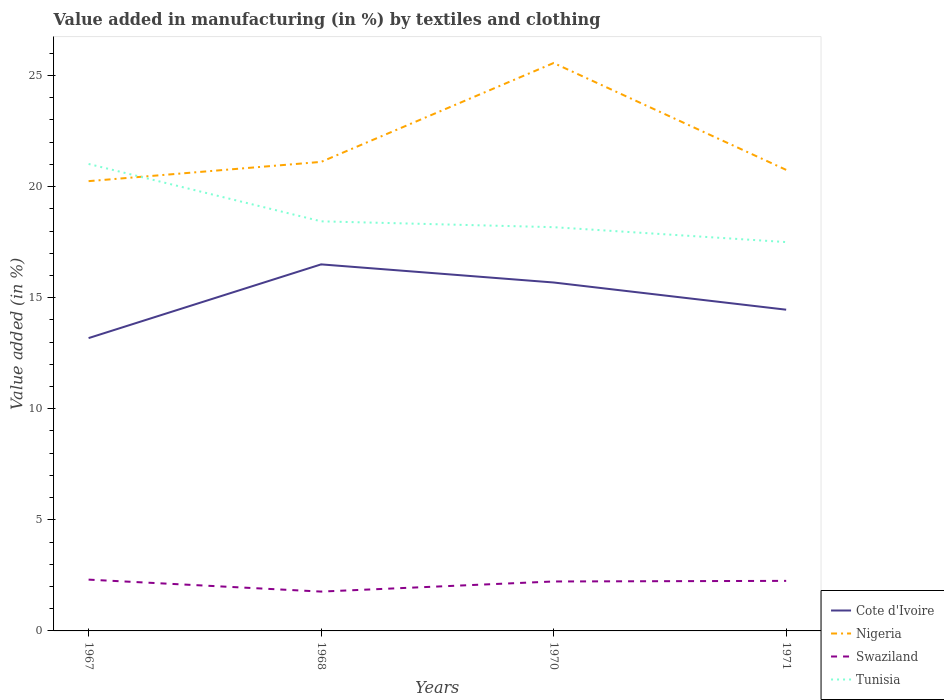Does the line corresponding to Cote d'Ivoire intersect with the line corresponding to Nigeria?
Offer a terse response. No. Is the number of lines equal to the number of legend labels?
Provide a succinct answer. Yes. Across all years, what is the maximum percentage of value added in manufacturing by textiles and clothing in Tunisia?
Your answer should be compact. 17.5. In which year was the percentage of value added in manufacturing by textiles and clothing in Swaziland maximum?
Provide a short and direct response. 1968. What is the total percentage of value added in manufacturing by textiles and clothing in Cote d'Ivoire in the graph?
Provide a short and direct response. 0.82. What is the difference between the highest and the second highest percentage of value added in manufacturing by textiles and clothing in Nigeria?
Your response must be concise. 5.32. How many lines are there?
Give a very brief answer. 4. Does the graph contain grids?
Give a very brief answer. No. How many legend labels are there?
Make the answer very short. 4. How are the legend labels stacked?
Your response must be concise. Vertical. What is the title of the graph?
Provide a succinct answer. Value added in manufacturing (in %) by textiles and clothing. What is the label or title of the Y-axis?
Offer a terse response. Value added (in %). What is the Value added (in %) in Cote d'Ivoire in 1967?
Make the answer very short. 13.18. What is the Value added (in %) in Nigeria in 1967?
Provide a short and direct response. 20.25. What is the Value added (in %) in Swaziland in 1967?
Keep it short and to the point. 2.31. What is the Value added (in %) of Tunisia in 1967?
Offer a terse response. 21.02. What is the Value added (in %) in Cote d'Ivoire in 1968?
Offer a very short reply. 16.5. What is the Value added (in %) of Nigeria in 1968?
Ensure brevity in your answer.  21.11. What is the Value added (in %) in Swaziland in 1968?
Your response must be concise. 1.77. What is the Value added (in %) of Tunisia in 1968?
Your answer should be very brief. 18.44. What is the Value added (in %) of Cote d'Ivoire in 1970?
Give a very brief answer. 15.68. What is the Value added (in %) of Nigeria in 1970?
Ensure brevity in your answer.  25.57. What is the Value added (in %) of Swaziland in 1970?
Provide a short and direct response. 2.23. What is the Value added (in %) in Tunisia in 1970?
Offer a terse response. 18.18. What is the Value added (in %) in Cote d'Ivoire in 1971?
Your answer should be very brief. 14.46. What is the Value added (in %) in Nigeria in 1971?
Offer a very short reply. 20.75. What is the Value added (in %) of Swaziland in 1971?
Your answer should be very brief. 2.25. What is the Value added (in %) of Tunisia in 1971?
Give a very brief answer. 17.5. Across all years, what is the maximum Value added (in %) in Cote d'Ivoire?
Offer a very short reply. 16.5. Across all years, what is the maximum Value added (in %) of Nigeria?
Your response must be concise. 25.57. Across all years, what is the maximum Value added (in %) of Swaziland?
Give a very brief answer. 2.31. Across all years, what is the maximum Value added (in %) of Tunisia?
Give a very brief answer. 21.02. Across all years, what is the minimum Value added (in %) in Cote d'Ivoire?
Your response must be concise. 13.18. Across all years, what is the minimum Value added (in %) of Nigeria?
Offer a very short reply. 20.25. Across all years, what is the minimum Value added (in %) in Swaziland?
Give a very brief answer. 1.77. Across all years, what is the minimum Value added (in %) in Tunisia?
Provide a short and direct response. 17.5. What is the total Value added (in %) of Cote d'Ivoire in the graph?
Ensure brevity in your answer.  59.83. What is the total Value added (in %) in Nigeria in the graph?
Make the answer very short. 87.68. What is the total Value added (in %) in Swaziland in the graph?
Your answer should be very brief. 8.56. What is the total Value added (in %) in Tunisia in the graph?
Keep it short and to the point. 75.14. What is the difference between the Value added (in %) in Cote d'Ivoire in 1967 and that in 1968?
Your response must be concise. -3.32. What is the difference between the Value added (in %) in Nigeria in 1967 and that in 1968?
Give a very brief answer. -0.87. What is the difference between the Value added (in %) in Swaziland in 1967 and that in 1968?
Your response must be concise. 0.54. What is the difference between the Value added (in %) of Tunisia in 1967 and that in 1968?
Your response must be concise. 2.58. What is the difference between the Value added (in %) in Cote d'Ivoire in 1967 and that in 1970?
Provide a succinct answer. -2.5. What is the difference between the Value added (in %) of Nigeria in 1967 and that in 1970?
Keep it short and to the point. -5.32. What is the difference between the Value added (in %) of Swaziland in 1967 and that in 1970?
Your response must be concise. 0.08. What is the difference between the Value added (in %) in Tunisia in 1967 and that in 1970?
Ensure brevity in your answer.  2.85. What is the difference between the Value added (in %) of Cote d'Ivoire in 1967 and that in 1971?
Provide a succinct answer. -1.28. What is the difference between the Value added (in %) of Nigeria in 1967 and that in 1971?
Ensure brevity in your answer.  -0.51. What is the difference between the Value added (in %) in Swaziland in 1967 and that in 1971?
Keep it short and to the point. 0.06. What is the difference between the Value added (in %) in Tunisia in 1967 and that in 1971?
Your response must be concise. 3.52. What is the difference between the Value added (in %) of Cote d'Ivoire in 1968 and that in 1970?
Your answer should be compact. 0.82. What is the difference between the Value added (in %) in Nigeria in 1968 and that in 1970?
Your answer should be compact. -4.45. What is the difference between the Value added (in %) of Swaziland in 1968 and that in 1970?
Give a very brief answer. -0.46. What is the difference between the Value added (in %) of Tunisia in 1968 and that in 1970?
Ensure brevity in your answer.  0.26. What is the difference between the Value added (in %) in Cote d'Ivoire in 1968 and that in 1971?
Make the answer very short. 2.04. What is the difference between the Value added (in %) of Nigeria in 1968 and that in 1971?
Your answer should be compact. 0.36. What is the difference between the Value added (in %) of Swaziland in 1968 and that in 1971?
Your answer should be very brief. -0.48. What is the difference between the Value added (in %) in Tunisia in 1968 and that in 1971?
Make the answer very short. 0.93. What is the difference between the Value added (in %) in Cote d'Ivoire in 1970 and that in 1971?
Offer a very short reply. 1.22. What is the difference between the Value added (in %) of Nigeria in 1970 and that in 1971?
Provide a short and direct response. 4.81. What is the difference between the Value added (in %) in Swaziland in 1970 and that in 1971?
Keep it short and to the point. -0.03. What is the difference between the Value added (in %) of Tunisia in 1970 and that in 1971?
Offer a terse response. 0.67. What is the difference between the Value added (in %) in Cote d'Ivoire in 1967 and the Value added (in %) in Nigeria in 1968?
Ensure brevity in your answer.  -7.93. What is the difference between the Value added (in %) of Cote d'Ivoire in 1967 and the Value added (in %) of Swaziland in 1968?
Your answer should be compact. 11.41. What is the difference between the Value added (in %) of Cote d'Ivoire in 1967 and the Value added (in %) of Tunisia in 1968?
Your answer should be very brief. -5.26. What is the difference between the Value added (in %) in Nigeria in 1967 and the Value added (in %) in Swaziland in 1968?
Provide a succinct answer. 18.48. What is the difference between the Value added (in %) of Nigeria in 1967 and the Value added (in %) of Tunisia in 1968?
Keep it short and to the point. 1.81. What is the difference between the Value added (in %) of Swaziland in 1967 and the Value added (in %) of Tunisia in 1968?
Offer a terse response. -16.13. What is the difference between the Value added (in %) in Cote d'Ivoire in 1967 and the Value added (in %) in Nigeria in 1970?
Your answer should be very brief. -12.38. What is the difference between the Value added (in %) in Cote d'Ivoire in 1967 and the Value added (in %) in Swaziland in 1970?
Your response must be concise. 10.96. What is the difference between the Value added (in %) in Cote d'Ivoire in 1967 and the Value added (in %) in Tunisia in 1970?
Your response must be concise. -4.99. What is the difference between the Value added (in %) in Nigeria in 1967 and the Value added (in %) in Swaziland in 1970?
Provide a short and direct response. 18.02. What is the difference between the Value added (in %) in Nigeria in 1967 and the Value added (in %) in Tunisia in 1970?
Ensure brevity in your answer.  2.07. What is the difference between the Value added (in %) of Swaziland in 1967 and the Value added (in %) of Tunisia in 1970?
Ensure brevity in your answer.  -15.87. What is the difference between the Value added (in %) in Cote d'Ivoire in 1967 and the Value added (in %) in Nigeria in 1971?
Your response must be concise. -7.57. What is the difference between the Value added (in %) of Cote d'Ivoire in 1967 and the Value added (in %) of Swaziland in 1971?
Give a very brief answer. 10.93. What is the difference between the Value added (in %) of Cote d'Ivoire in 1967 and the Value added (in %) of Tunisia in 1971?
Keep it short and to the point. -4.32. What is the difference between the Value added (in %) of Nigeria in 1967 and the Value added (in %) of Swaziland in 1971?
Keep it short and to the point. 17.99. What is the difference between the Value added (in %) in Nigeria in 1967 and the Value added (in %) in Tunisia in 1971?
Make the answer very short. 2.74. What is the difference between the Value added (in %) of Swaziland in 1967 and the Value added (in %) of Tunisia in 1971?
Offer a very short reply. -15.2. What is the difference between the Value added (in %) of Cote d'Ivoire in 1968 and the Value added (in %) of Nigeria in 1970?
Your response must be concise. -9.07. What is the difference between the Value added (in %) of Cote d'Ivoire in 1968 and the Value added (in %) of Swaziland in 1970?
Offer a terse response. 14.27. What is the difference between the Value added (in %) of Cote d'Ivoire in 1968 and the Value added (in %) of Tunisia in 1970?
Provide a short and direct response. -1.67. What is the difference between the Value added (in %) of Nigeria in 1968 and the Value added (in %) of Swaziland in 1970?
Offer a terse response. 18.89. What is the difference between the Value added (in %) in Nigeria in 1968 and the Value added (in %) in Tunisia in 1970?
Offer a terse response. 2.94. What is the difference between the Value added (in %) of Swaziland in 1968 and the Value added (in %) of Tunisia in 1970?
Ensure brevity in your answer.  -16.4. What is the difference between the Value added (in %) of Cote d'Ivoire in 1968 and the Value added (in %) of Nigeria in 1971?
Your response must be concise. -4.25. What is the difference between the Value added (in %) of Cote d'Ivoire in 1968 and the Value added (in %) of Swaziland in 1971?
Provide a short and direct response. 14.25. What is the difference between the Value added (in %) in Cote d'Ivoire in 1968 and the Value added (in %) in Tunisia in 1971?
Provide a short and direct response. -1. What is the difference between the Value added (in %) in Nigeria in 1968 and the Value added (in %) in Swaziland in 1971?
Provide a short and direct response. 18.86. What is the difference between the Value added (in %) in Nigeria in 1968 and the Value added (in %) in Tunisia in 1971?
Your answer should be compact. 3.61. What is the difference between the Value added (in %) of Swaziland in 1968 and the Value added (in %) of Tunisia in 1971?
Provide a short and direct response. -15.73. What is the difference between the Value added (in %) in Cote d'Ivoire in 1970 and the Value added (in %) in Nigeria in 1971?
Provide a succinct answer. -5.07. What is the difference between the Value added (in %) of Cote d'Ivoire in 1970 and the Value added (in %) of Swaziland in 1971?
Give a very brief answer. 13.43. What is the difference between the Value added (in %) in Cote d'Ivoire in 1970 and the Value added (in %) in Tunisia in 1971?
Your answer should be very brief. -1.82. What is the difference between the Value added (in %) of Nigeria in 1970 and the Value added (in %) of Swaziland in 1971?
Your answer should be compact. 23.31. What is the difference between the Value added (in %) in Nigeria in 1970 and the Value added (in %) in Tunisia in 1971?
Keep it short and to the point. 8.06. What is the difference between the Value added (in %) in Swaziland in 1970 and the Value added (in %) in Tunisia in 1971?
Your answer should be compact. -15.28. What is the average Value added (in %) in Cote d'Ivoire per year?
Ensure brevity in your answer.  14.96. What is the average Value added (in %) of Nigeria per year?
Give a very brief answer. 21.92. What is the average Value added (in %) of Swaziland per year?
Provide a succinct answer. 2.14. What is the average Value added (in %) of Tunisia per year?
Make the answer very short. 18.78. In the year 1967, what is the difference between the Value added (in %) of Cote d'Ivoire and Value added (in %) of Nigeria?
Your answer should be compact. -7.07. In the year 1967, what is the difference between the Value added (in %) of Cote d'Ivoire and Value added (in %) of Swaziland?
Your response must be concise. 10.87. In the year 1967, what is the difference between the Value added (in %) in Cote d'Ivoire and Value added (in %) in Tunisia?
Provide a short and direct response. -7.84. In the year 1967, what is the difference between the Value added (in %) of Nigeria and Value added (in %) of Swaziland?
Provide a short and direct response. 17.94. In the year 1967, what is the difference between the Value added (in %) in Nigeria and Value added (in %) in Tunisia?
Your answer should be compact. -0.77. In the year 1967, what is the difference between the Value added (in %) of Swaziland and Value added (in %) of Tunisia?
Ensure brevity in your answer.  -18.71. In the year 1968, what is the difference between the Value added (in %) in Cote d'Ivoire and Value added (in %) in Nigeria?
Provide a succinct answer. -4.61. In the year 1968, what is the difference between the Value added (in %) of Cote d'Ivoire and Value added (in %) of Swaziland?
Offer a very short reply. 14.73. In the year 1968, what is the difference between the Value added (in %) of Cote d'Ivoire and Value added (in %) of Tunisia?
Offer a terse response. -1.94. In the year 1968, what is the difference between the Value added (in %) in Nigeria and Value added (in %) in Swaziland?
Offer a very short reply. 19.34. In the year 1968, what is the difference between the Value added (in %) in Nigeria and Value added (in %) in Tunisia?
Your answer should be very brief. 2.68. In the year 1968, what is the difference between the Value added (in %) of Swaziland and Value added (in %) of Tunisia?
Make the answer very short. -16.67. In the year 1970, what is the difference between the Value added (in %) in Cote d'Ivoire and Value added (in %) in Nigeria?
Your answer should be very brief. -9.88. In the year 1970, what is the difference between the Value added (in %) in Cote d'Ivoire and Value added (in %) in Swaziland?
Your answer should be very brief. 13.46. In the year 1970, what is the difference between the Value added (in %) in Cote d'Ivoire and Value added (in %) in Tunisia?
Provide a short and direct response. -2.49. In the year 1970, what is the difference between the Value added (in %) in Nigeria and Value added (in %) in Swaziland?
Ensure brevity in your answer.  23.34. In the year 1970, what is the difference between the Value added (in %) in Nigeria and Value added (in %) in Tunisia?
Offer a very short reply. 7.39. In the year 1970, what is the difference between the Value added (in %) in Swaziland and Value added (in %) in Tunisia?
Give a very brief answer. -15.95. In the year 1971, what is the difference between the Value added (in %) of Cote d'Ivoire and Value added (in %) of Nigeria?
Give a very brief answer. -6.29. In the year 1971, what is the difference between the Value added (in %) of Cote d'Ivoire and Value added (in %) of Swaziland?
Your answer should be compact. 12.21. In the year 1971, what is the difference between the Value added (in %) of Cote d'Ivoire and Value added (in %) of Tunisia?
Make the answer very short. -3.04. In the year 1971, what is the difference between the Value added (in %) of Nigeria and Value added (in %) of Swaziland?
Provide a short and direct response. 18.5. In the year 1971, what is the difference between the Value added (in %) of Nigeria and Value added (in %) of Tunisia?
Provide a succinct answer. 3.25. In the year 1971, what is the difference between the Value added (in %) of Swaziland and Value added (in %) of Tunisia?
Ensure brevity in your answer.  -15.25. What is the ratio of the Value added (in %) of Cote d'Ivoire in 1967 to that in 1968?
Ensure brevity in your answer.  0.8. What is the ratio of the Value added (in %) of Nigeria in 1967 to that in 1968?
Keep it short and to the point. 0.96. What is the ratio of the Value added (in %) in Swaziland in 1967 to that in 1968?
Offer a very short reply. 1.3. What is the ratio of the Value added (in %) of Tunisia in 1967 to that in 1968?
Keep it short and to the point. 1.14. What is the ratio of the Value added (in %) of Cote d'Ivoire in 1967 to that in 1970?
Give a very brief answer. 0.84. What is the ratio of the Value added (in %) in Nigeria in 1967 to that in 1970?
Provide a short and direct response. 0.79. What is the ratio of the Value added (in %) of Swaziland in 1967 to that in 1970?
Provide a short and direct response. 1.04. What is the ratio of the Value added (in %) in Tunisia in 1967 to that in 1970?
Offer a terse response. 1.16. What is the ratio of the Value added (in %) of Cote d'Ivoire in 1967 to that in 1971?
Offer a terse response. 0.91. What is the ratio of the Value added (in %) of Nigeria in 1967 to that in 1971?
Provide a short and direct response. 0.98. What is the ratio of the Value added (in %) in Swaziland in 1967 to that in 1971?
Offer a terse response. 1.02. What is the ratio of the Value added (in %) in Tunisia in 1967 to that in 1971?
Give a very brief answer. 1.2. What is the ratio of the Value added (in %) in Cote d'Ivoire in 1968 to that in 1970?
Offer a very short reply. 1.05. What is the ratio of the Value added (in %) of Nigeria in 1968 to that in 1970?
Your answer should be compact. 0.83. What is the ratio of the Value added (in %) in Swaziland in 1968 to that in 1970?
Your response must be concise. 0.8. What is the ratio of the Value added (in %) of Tunisia in 1968 to that in 1970?
Your answer should be very brief. 1.01. What is the ratio of the Value added (in %) of Cote d'Ivoire in 1968 to that in 1971?
Offer a very short reply. 1.14. What is the ratio of the Value added (in %) in Nigeria in 1968 to that in 1971?
Provide a short and direct response. 1.02. What is the ratio of the Value added (in %) of Swaziland in 1968 to that in 1971?
Make the answer very short. 0.79. What is the ratio of the Value added (in %) in Tunisia in 1968 to that in 1971?
Your response must be concise. 1.05. What is the ratio of the Value added (in %) in Cote d'Ivoire in 1970 to that in 1971?
Your answer should be compact. 1.08. What is the ratio of the Value added (in %) of Nigeria in 1970 to that in 1971?
Your answer should be compact. 1.23. What is the ratio of the Value added (in %) in Tunisia in 1970 to that in 1971?
Your response must be concise. 1.04. What is the difference between the highest and the second highest Value added (in %) in Cote d'Ivoire?
Offer a terse response. 0.82. What is the difference between the highest and the second highest Value added (in %) in Nigeria?
Provide a succinct answer. 4.45. What is the difference between the highest and the second highest Value added (in %) in Swaziland?
Make the answer very short. 0.06. What is the difference between the highest and the second highest Value added (in %) of Tunisia?
Your response must be concise. 2.58. What is the difference between the highest and the lowest Value added (in %) of Cote d'Ivoire?
Your answer should be very brief. 3.32. What is the difference between the highest and the lowest Value added (in %) in Nigeria?
Offer a terse response. 5.32. What is the difference between the highest and the lowest Value added (in %) of Swaziland?
Give a very brief answer. 0.54. What is the difference between the highest and the lowest Value added (in %) of Tunisia?
Give a very brief answer. 3.52. 